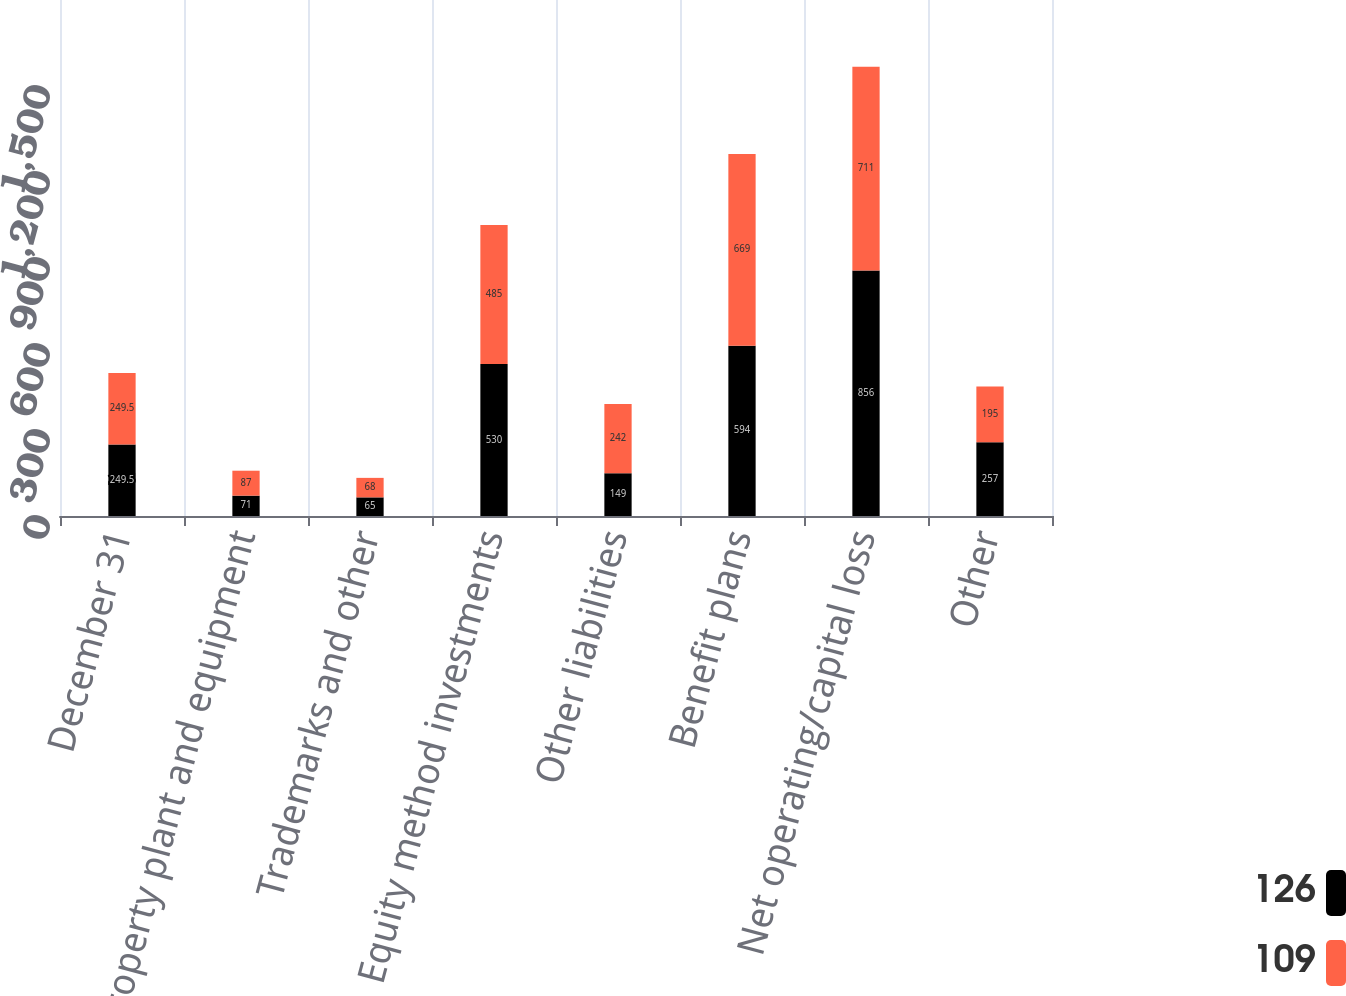<chart> <loc_0><loc_0><loc_500><loc_500><stacked_bar_chart><ecel><fcel>December 31<fcel>Property plant and equipment<fcel>Trademarks and other<fcel>Equity method investments<fcel>Other liabilities<fcel>Benefit plans<fcel>Net operating/capital loss<fcel>Other<nl><fcel>126<fcel>249.5<fcel>71<fcel>65<fcel>530<fcel>149<fcel>594<fcel>856<fcel>257<nl><fcel>109<fcel>249.5<fcel>87<fcel>68<fcel>485<fcel>242<fcel>669<fcel>711<fcel>195<nl></chart> 